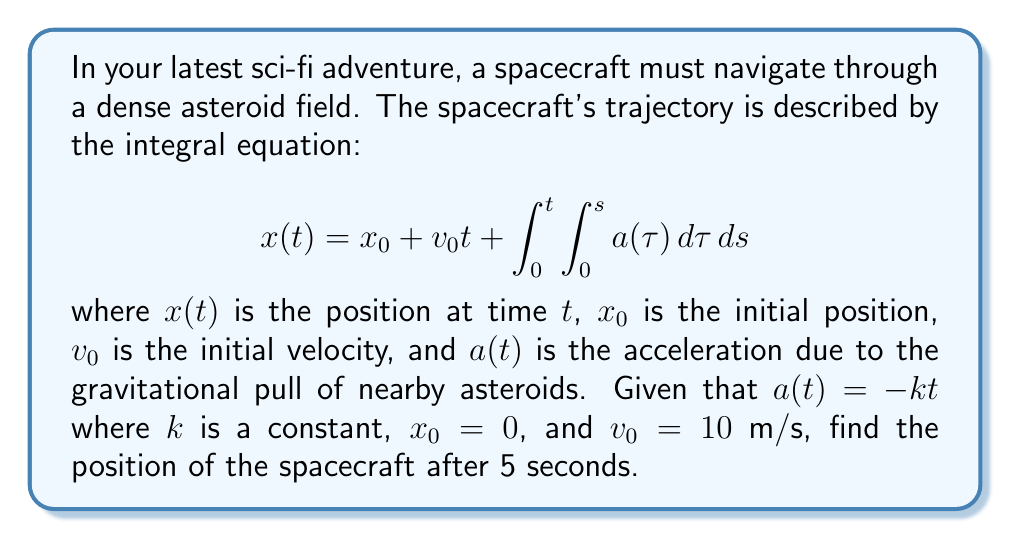What is the answer to this math problem? Let's solve this step-by-step:

1) We start with the given integral equation:
   $$x(t) = x_0 + v_0t + \int_0^t \int_0^s a(\tau) d\tau ds$$

2) We're given that $a(t) = -kt$, $x_0 = 0$, and $v_0 = 10$ m/s. Let's substitute these:
   $$x(t) = 0 + 10t + \int_0^t \int_0^s (-k\tau) d\tau ds$$

3) Let's solve the inner integral first:
   $$\int_0^s (-k\tau) d\tau = -k \frac{\tau^2}{2} \bigg|_0^s = -k \frac{s^2}{2}$$

4) Now our equation looks like this:
   $$x(t) = 10t + \int_0^t (-k \frac{s^2}{2}) ds$$

5) Solve the remaining integral:
   $$x(t) = 10t + (-k \frac{s^3}{6}) \bigg|_0^t = 10t - k \frac{t^3}{6}$$

6) This is our final equation for the position of the spacecraft at any time $t$.

7) We need to find the position after 5 seconds, so let's substitute $t = 5$:
   $$x(5) = 10(5) - k \frac{5^3}{6} = 50 - \frac{125k}{6}$$

8) The final position depends on the value of $k$, which wasn't specified in the problem. We can leave our answer in terms of $k$.
Answer: $50 - \frac{125k}{6}$ meters 